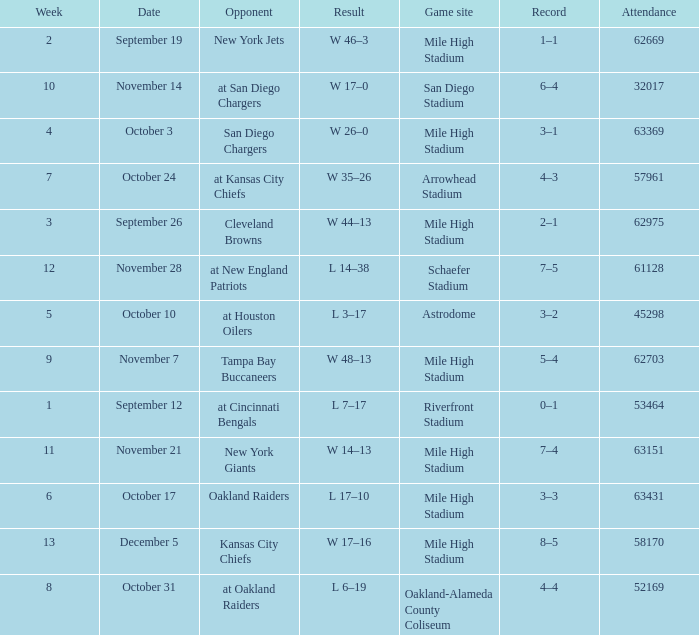Would you mind parsing the complete table? {'header': ['Week', 'Date', 'Opponent', 'Result', 'Game site', 'Record', 'Attendance'], 'rows': [['2', 'September 19', 'New York Jets', 'W 46–3', 'Mile High Stadium', '1–1', '62669'], ['10', 'November 14', 'at San Diego Chargers', 'W 17–0', 'San Diego Stadium', '6–4', '32017'], ['4', 'October 3', 'San Diego Chargers', 'W 26–0', 'Mile High Stadium', '3–1', '63369'], ['7', 'October 24', 'at Kansas City Chiefs', 'W 35–26', 'Arrowhead Stadium', '4–3', '57961'], ['3', 'September 26', 'Cleveland Browns', 'W 44–13', 'Mile High Stadium', '2–1', '62975'], ['12', 'November 28', 'at New England Patriots', 'L 14–38', 'Schaefer Stadium', '7–5', '61128'], ['5', 'October 10', 'at Houston Oilers', 'L 3–17', 'Astrodome', '3–2', '45298'], ['9', 'November 7', 'Tampa Bay Buccaneers', 'W 48–13', 'Mile High Stadium', '5–4', '62703'], ['1', 'September 12', 'at Cincinnati Bengals', 'L 7–17', 'Riverfront Stadium', '0–1', '53464'], ['11', 'November 21', 'New York Giants', 'W 14–13', 'Mile High Stadium', '7–4', '63151'], ['6', 'October 17', 'Oakland Raiders', 'L 17–10', 'Mile High Stadium', '3–3', '63431'], ['13', 'December 5', 'Kansas City Chiefs', 'W 17–16', 'Mile High Stadium', '8–5', '58170'], ['8', 'October 31', 'at Oakland Raiders', 'L 6–19', 'Oakland-Alameda County Coliseum', '4–4', '52169']]} What was the week digit when the rival was the new york jets? 2.0. 